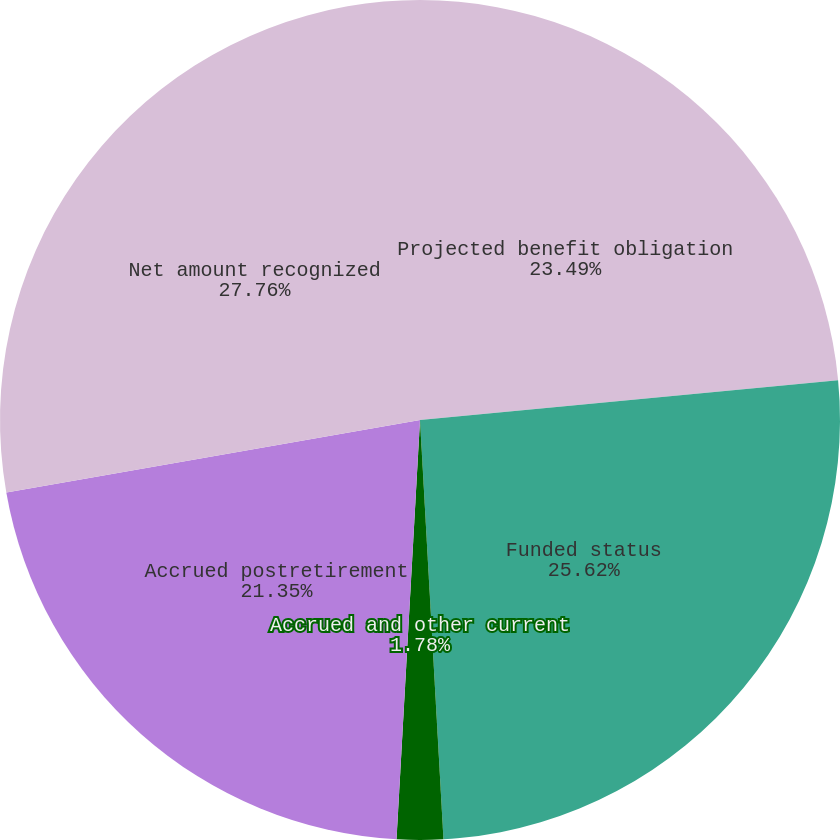Convert chart to OTSL. <chart><loc_0><loc_0><loc_500><loc_500><pie_chart><fcel>Projected benefit obligation<fcel>Funded status<fcel>Accrued and other current<fcel>Accrued postretirement<fcel>Net amount recognized<nl><fcel>23.49%<fcel>25.62%<fcel>1.78%<fcel>21.35%<fcel>27.76%<nl></chart> 